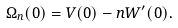<formula> <loc_0><loc_0><loc_500><loc_500>\Omega _ { n } ( 0 ) = V ( 0 ) - n W ^ { \prime } ( 0 ) .</formula> 